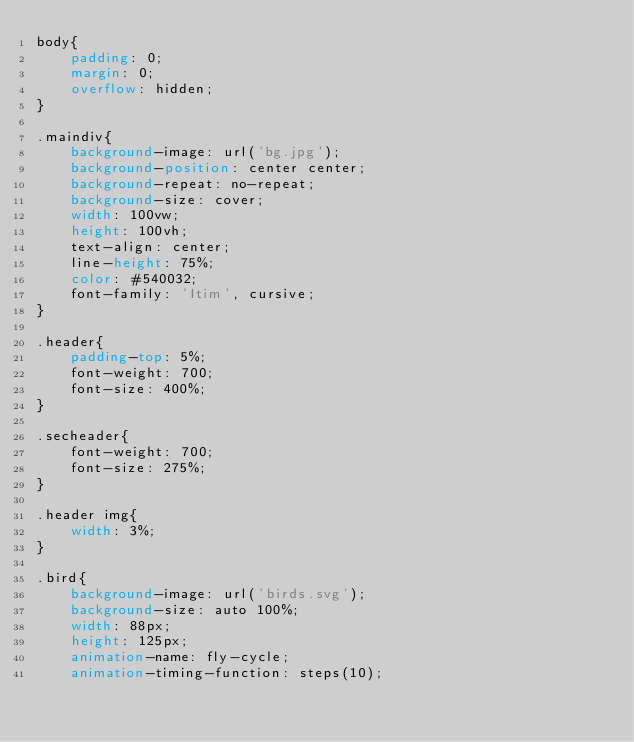Convert code to text. <code><loc_0><loc_0><loc_500><loc_500><_CSS_>body{
    padding: 0;
    margin: 0;
    overflow: hidden;
}

.maindiv{
    background-image: url('bg.jpg');
    background-position: center center;
    background-repeat: no-repeat;
    background-size: cover;
    width: 100vw;
    height: 100vh;
    text-align: center;
    line-height: 75%;
    color: #540032;
    font-family: 'Itim', cursive;
}

.header{
    padding-top: 5%;
    font-weight: 700;
    font-size: 400%;
}

.secheader{
    font-weight: 700;
    font-size: 275%;
}

.header img{
    width: 3%;
}

.bird{
    background-image: url('birds.svg');
    background-size: auto 100%;
    width: 88px;
    height: 125px;
    animation-name: fly-cycle;
    animation-timing-function: steps(10);</code> 